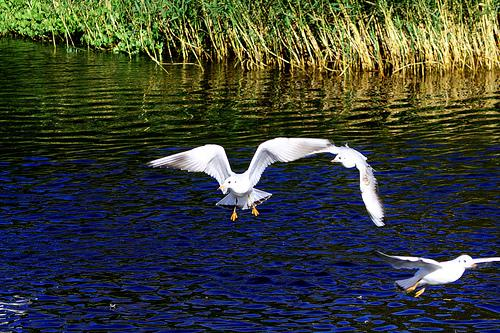Question: how many birds?
Choices:
A. 1.
B. 4.
C. 5.
D. 3.
Answer with the letter. Answer: D Question: where are they?
Choices:
A. Over the water.
B. In the office.
C. Out of state.
D. At home.
Answer with the letter. Answer: A Question: what is in the water?
Choices:
A. Grass.
B. Fish.
C. Seaweed.
D. Milk.
Answer with the letter. Answer: A Question: who is watching them?
Choices:
A. Dogs.
B. The government.
C. People.
D. A camera.
Answer with the letter. Answer: C 